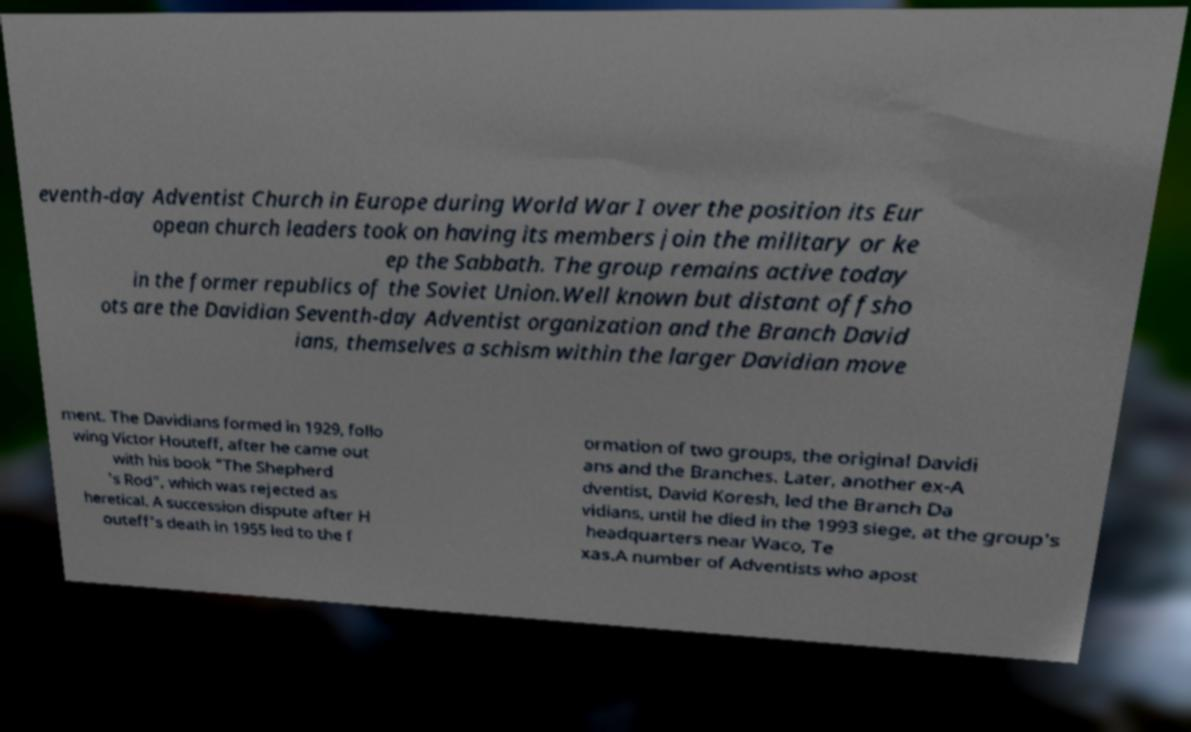Please identify and transcribe the text found in this image. eventh-day Adventist Church in Europe during World War I over the position its Eur opean church leaders took on having its members join the military or ke ep the Sabbath. The group remains active today in the former republics of the Soviet Union.Well known but distant offsho ots are the Davidian Seventh-day Adventist organization and the Branch David ians, themselves a schism within the larger Davidian move ment. The Davidians formed in 1929, follo wing Victor Houteff, after he came out with his book "The Shepherd 's Rod", which was rejected as heretical. A succession dispute after H outeff's death in 1955 led to the f ormation of two groups, the original Davidi ans and the Branches. Later, another ex-A dventist, David Koresh, led the Branch Da vidians, until he died in the 1993 siege, at the group's headquarters near Waco, Te xas.A number of Adventists who apost 